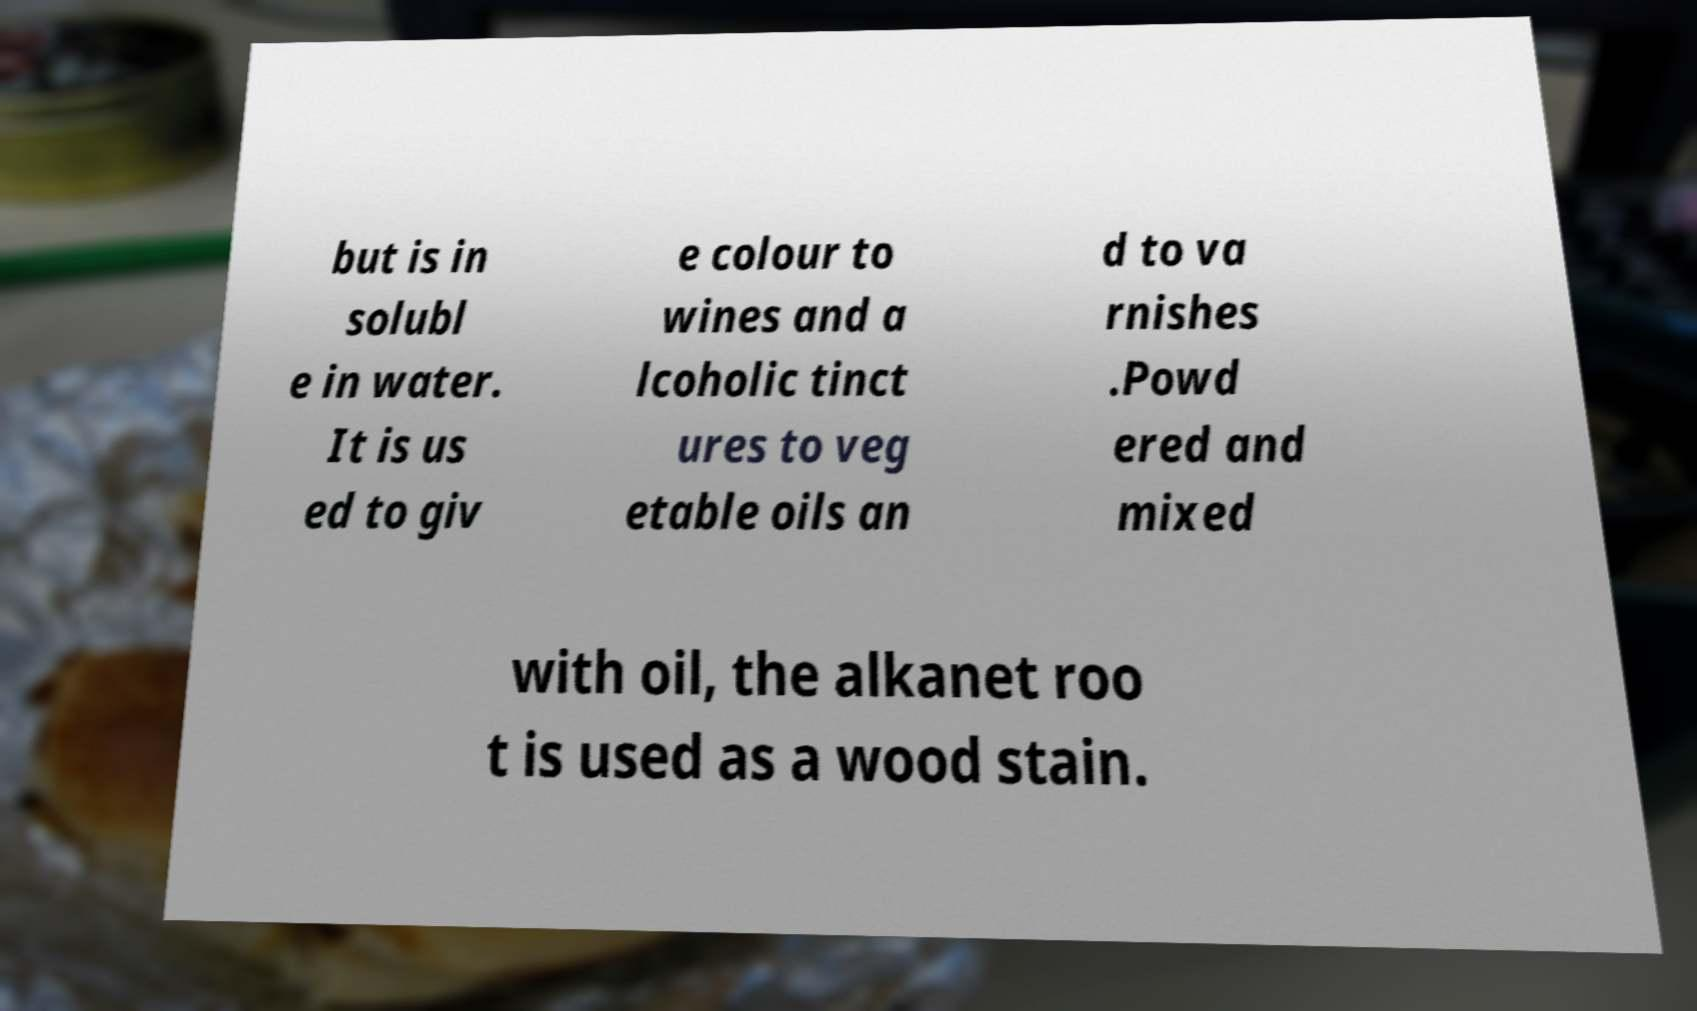Please read and relay the text visible in this image. What does it say? but is in solubl e in water. It is us ed to giv e colour to wines and a lcoholic tinct ures to veg etable oils an d to va rnishes .Powd ered and mixed with oil, the alkanet roo t is used as a wood stain. 